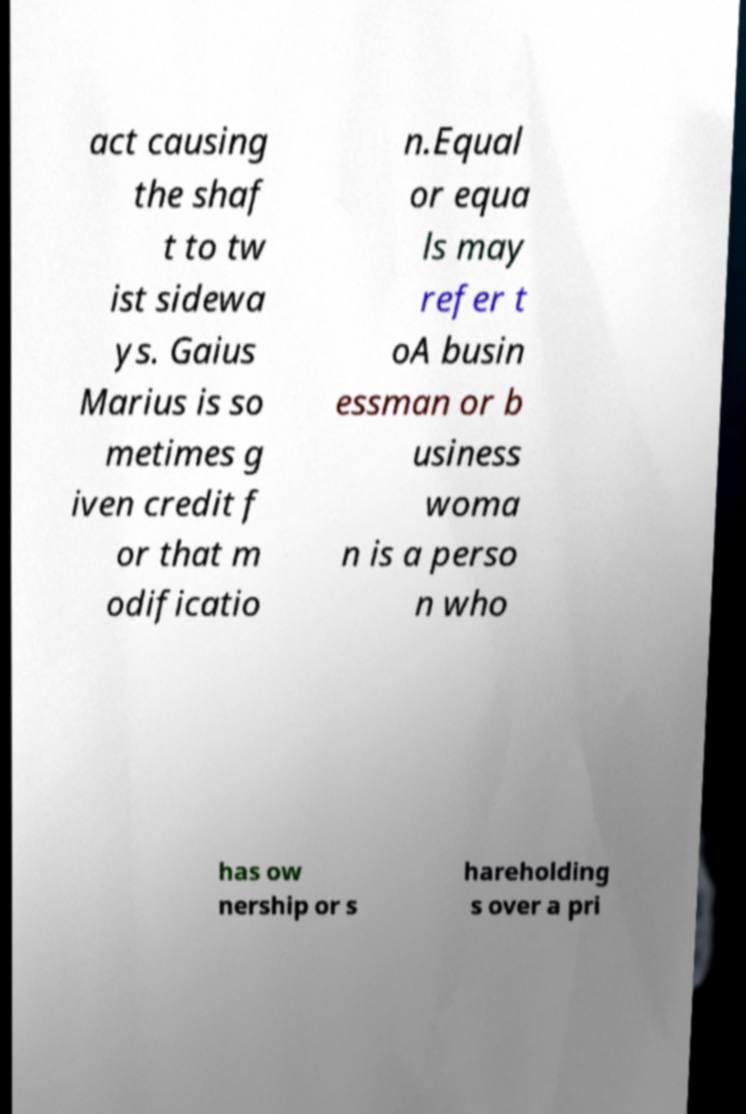For documentation purposes, I need the text within this image transcribed. Could you provide that? act causing the shaf t to tw ist sidewa ys. Gaius Marius is so metimes g iven credit f or that m odificatio n.Equal or equa ls may refer t oA busin essman or b usiness woma n is a perso n who has ow nership or s hareholding s over a pri 